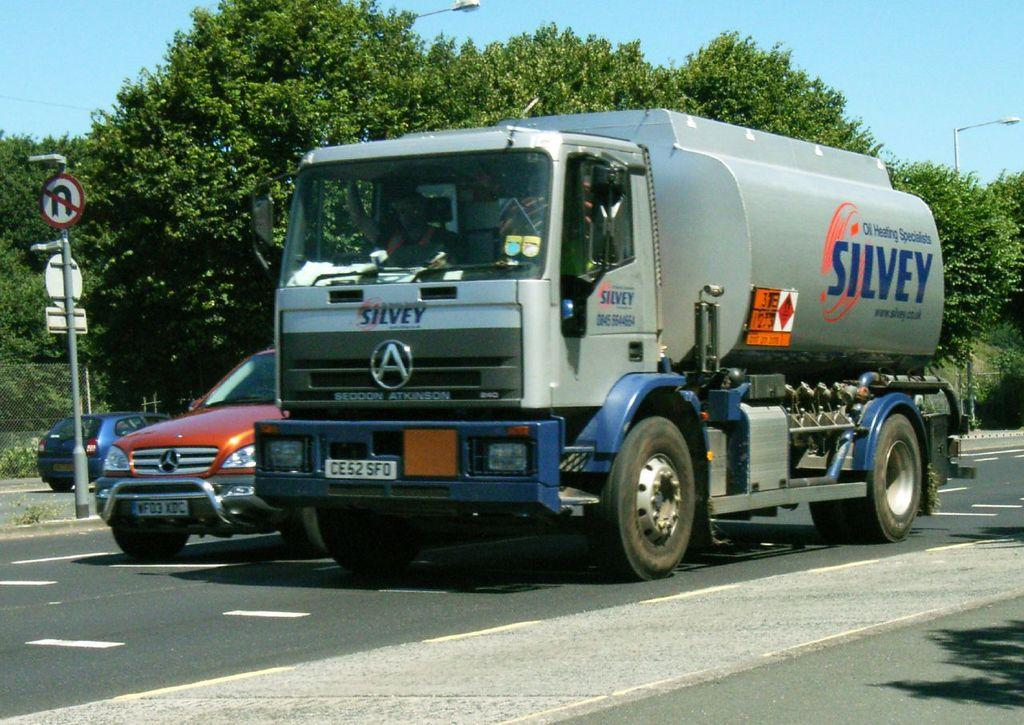What type of vehicle is on the road in the image? There is a truck on the road in the image. How many other vehicles are near the truck? There are two cars beside the truck. What can be seen in the background of the image? There are trees in the background. Where is the coach located in the image? There is no coach present in the image. What type of mailbox can be seen beside the truck? There is no mailbox present in the image. 